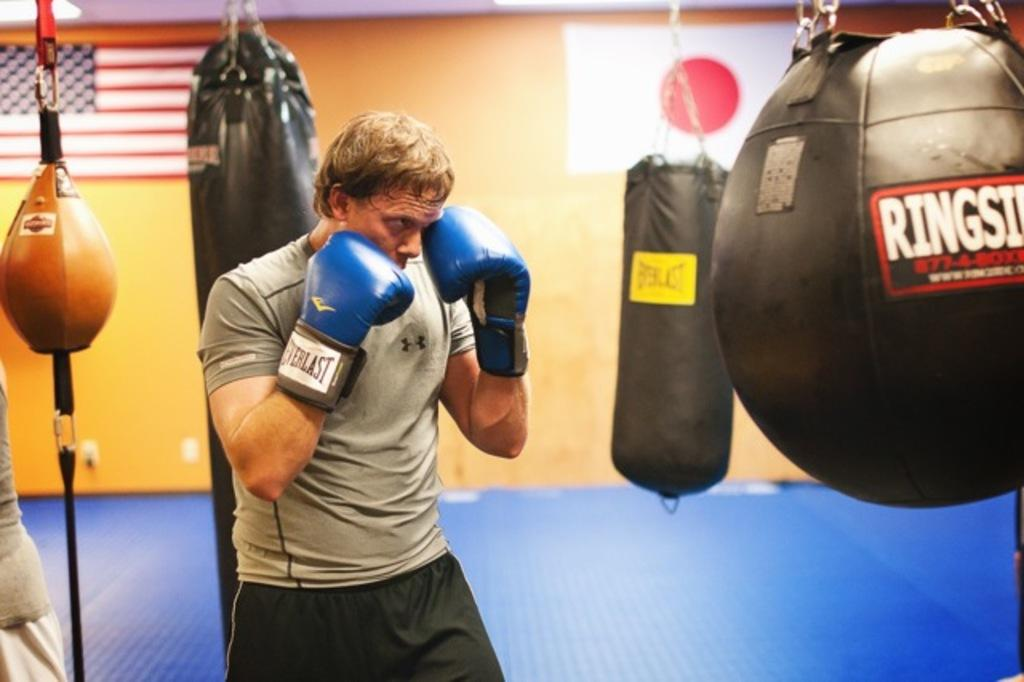Provide a one-sentence caption for the provided image. The boxer is wearing Everlast boxing gloves while bunching a bag. 